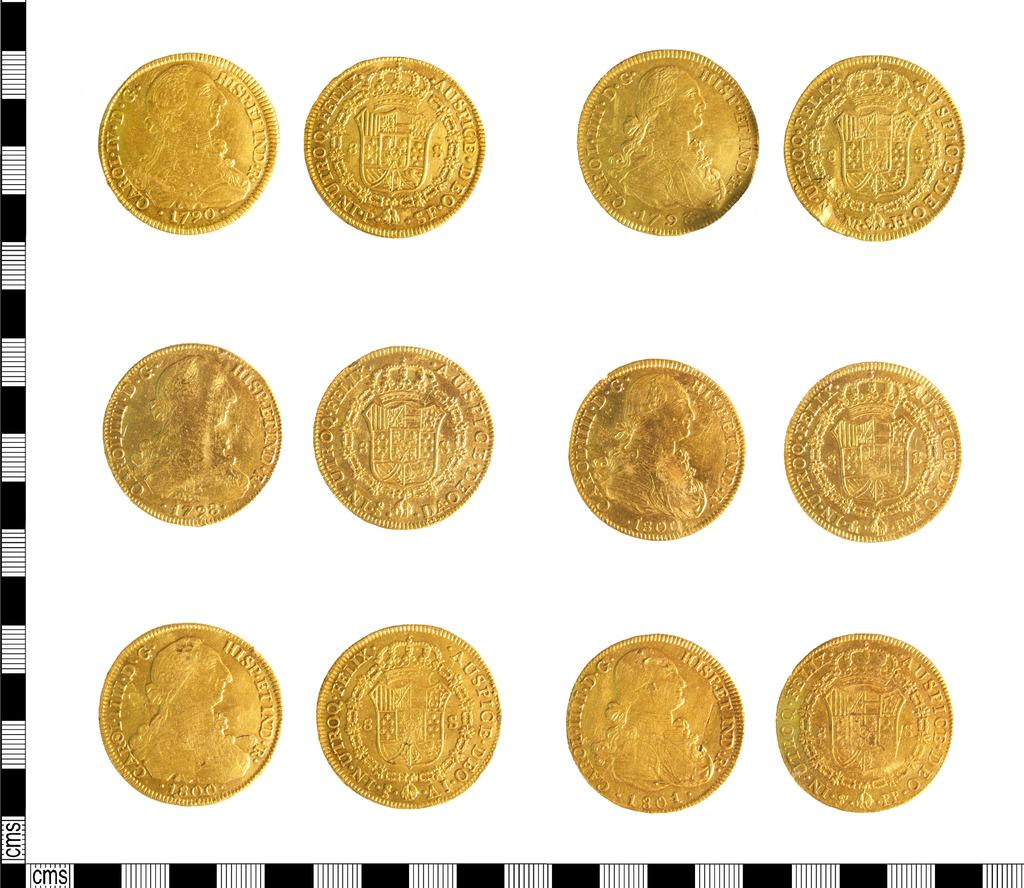<image>
Relay a brief, clear account of the picture shown. Twelve gold colored coins with some of them labeled Auspice. 